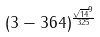<formula> <loc_0><loc_0><loc_500><loc_500>( 3 - 3 6 4 ) ^ { \frac { \sqrt { 1 4 } ^ { 9 } } { 3 2 5 } }</formula> 